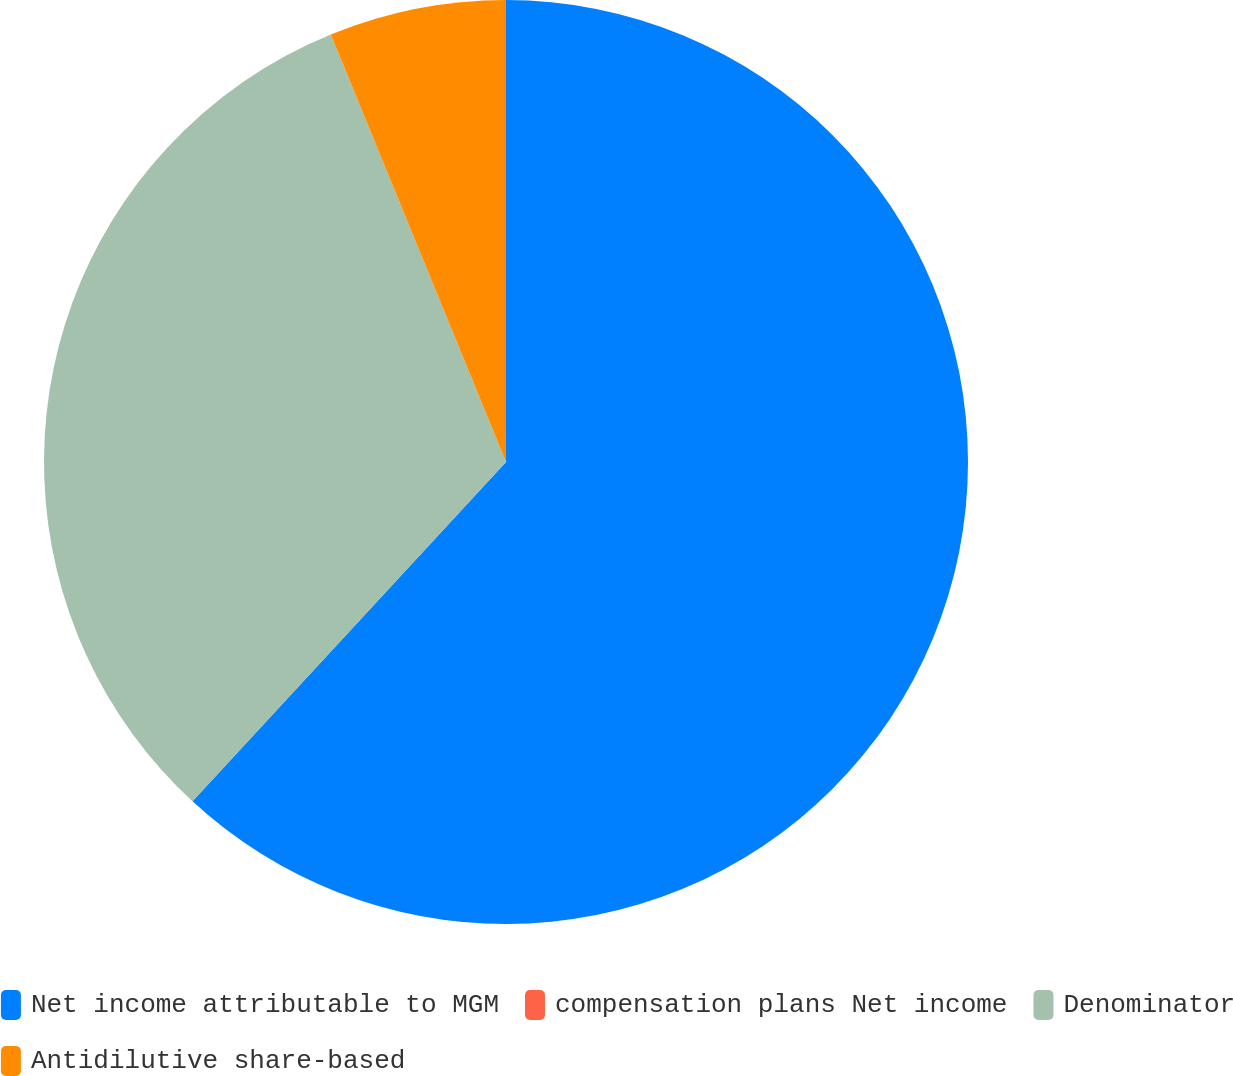<chart> <loc_0><loc_0><loc_500><loc_500><pie_chart><fcel>Net income attributable to MGM<fcel>compensation plans Net income<fcel>Denominator<fcel>Antidilutive share-based<nl><fcel>61.87%<fcel>0.0%<fcel>31.94%<fcel>6.19%<nl></chart> 